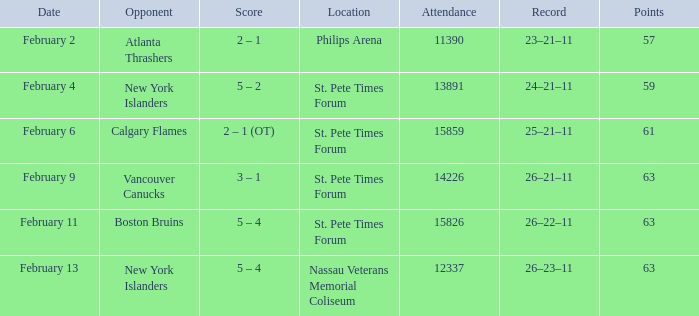What scores happened to be on February 9? 3 – 1. 